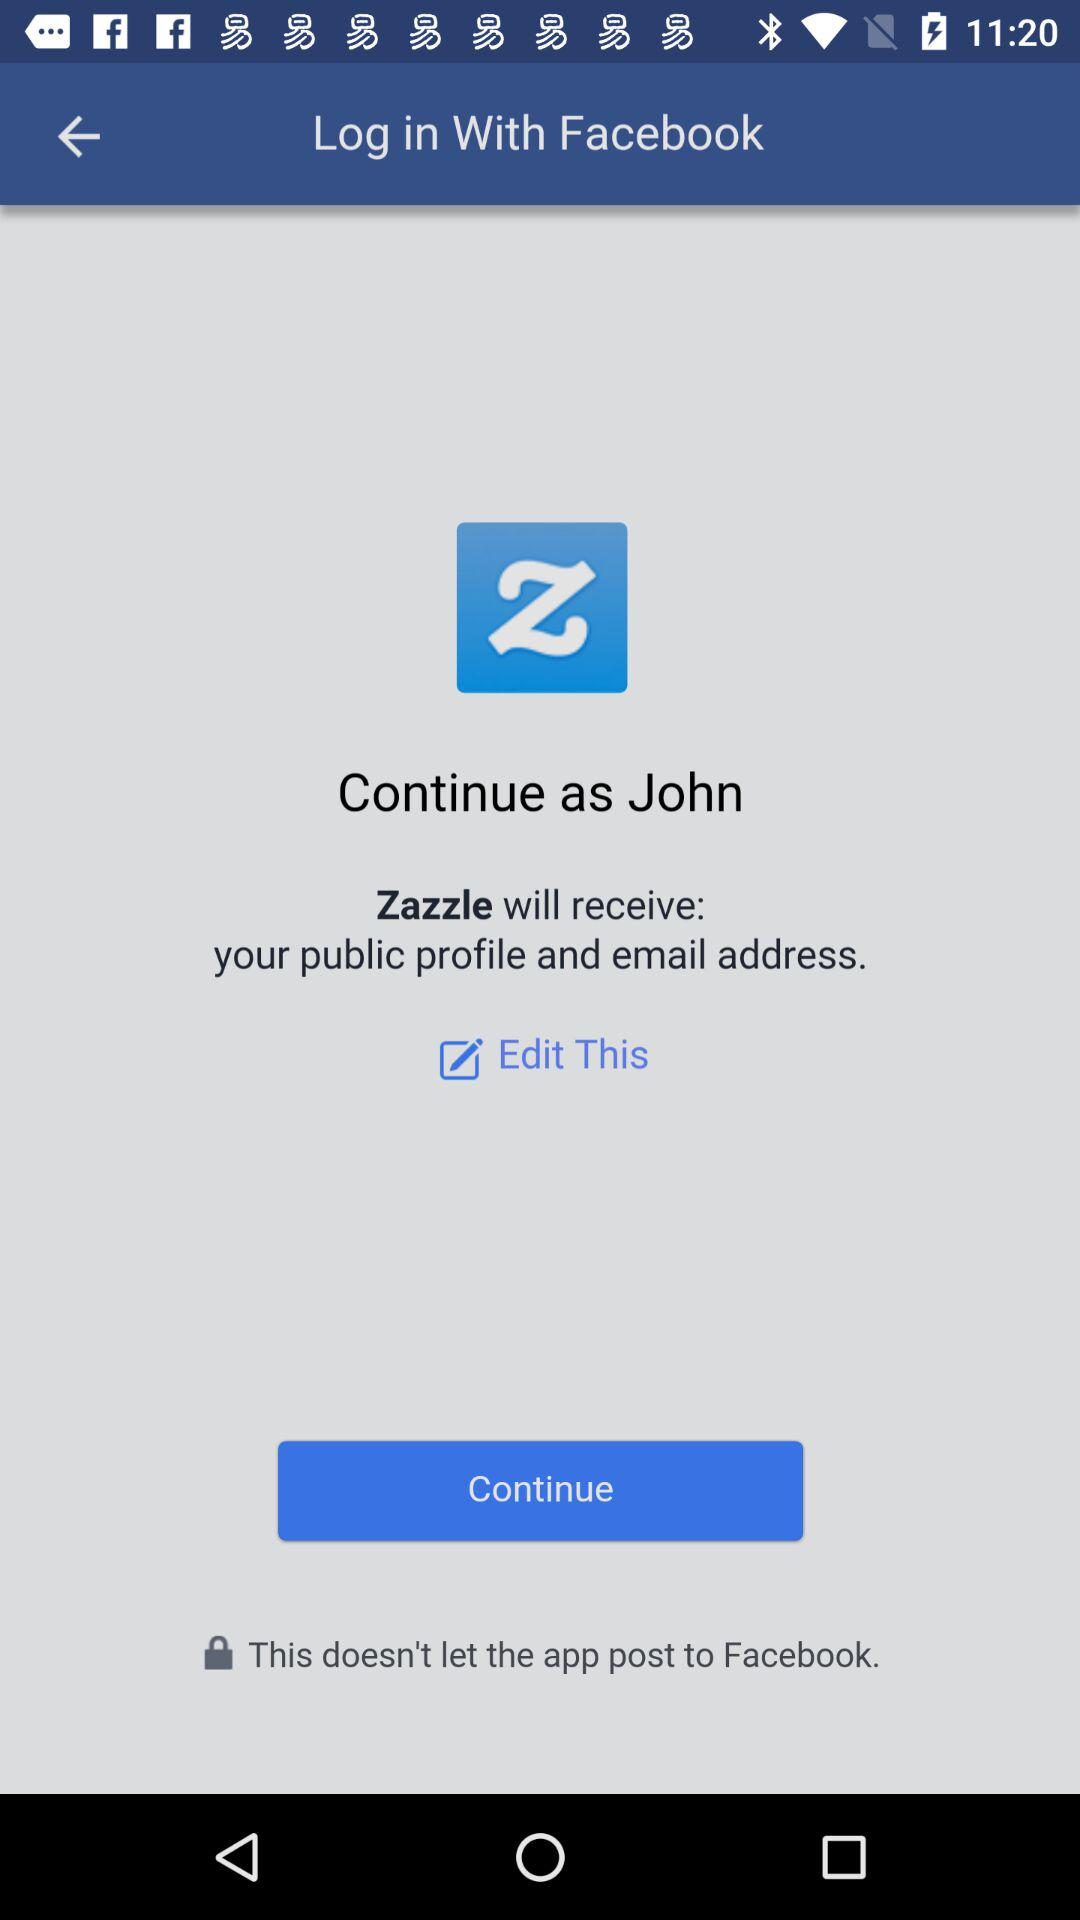What is the user name? The user name is John. 